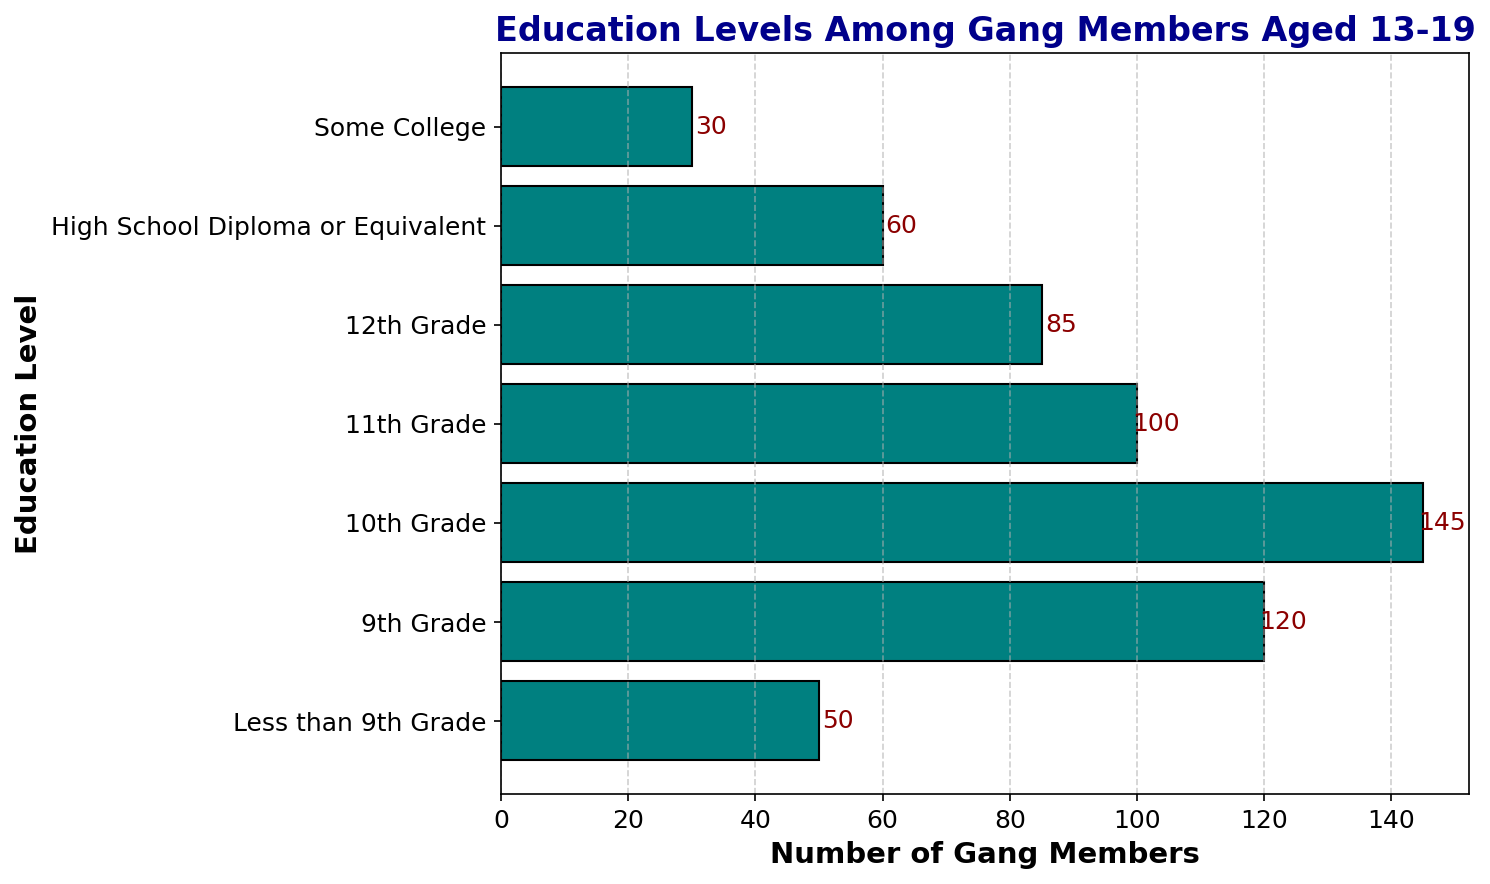What is the most common education level among gang members? By looking at the heights of the bars, the highest bar corresponds to the education level with the most gang members. The 10th Grade bar is the highest, indicating it is the most common.
Answer: 10th Grade How many gang members have completed high school or higher? Add the number of gang members for "High School Diploma or Equivalent" and "Some College": 60 + 30 = 90.
Answer: 90 Which education level has the fewest number of gang members? The shortest bar corresponds to "Some College," indicating it has the fewest gang members.
Answer: Some College How many more gang members are there in the 10th grade compared to those with a high school diploma or equivalent? Subtract the number of gang members with a high school diploma from those in the 10th grade: 145 - 60 = 85.
Answer: 85 What is the total number of gang members in the dataset? Sum all the values: 50 + 120 + 145 + 100 + 85 + 60 + 30 = 590.
Answer: 590 How many gang members are in the 11th and 12th grades combined? Add the number of gang members in the 11th and 12th grades: 100 + 85 = 185.
Answer: 185 Which education level has more gang members: 9th Grade or Less than 9th Grade? Compare the bars for 9th Grade (120) and Less than 9th Grade (50). The 9th Grade bar is taller.
Answer: 9th Grade What percentage of gang members have an education level of 11th grade? Divide the number of 11th grade gang members by the total number of gang members and multiply by 100: (100 / 590) * 100 ≈ 16.95%.
Answer: ~16.95% How does the number of gang members in 12th grade compare to those in the 9th grade? Subtract the number of gang members in the 12th grade from those in the 9th grade: 120 - 85 = 35. There are 35 more gang members in the 9th grade compared to the 12th grade.
Answer: 35 more in 9th Grade Is the number of gang members with a high school diploma greater than those with less than 9th grade education? Compare the numbers: 60 (high school diploma) and 50 (less than 9th grade). 60 > 50.
Answer: Yes 